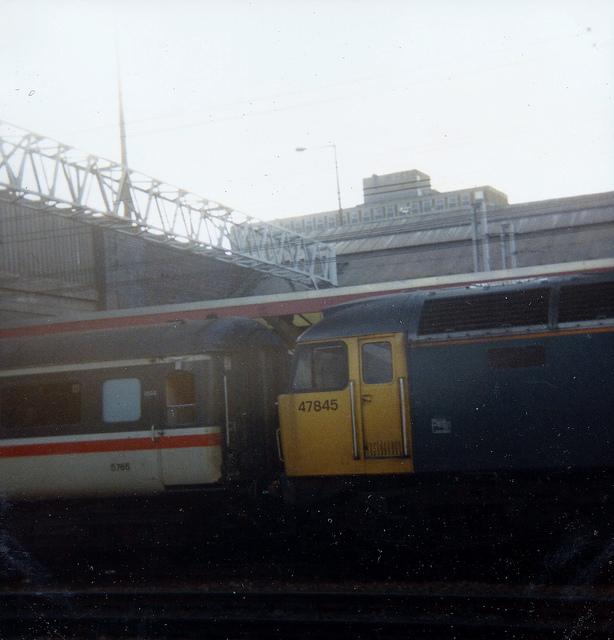How many train cars are there?
Give a very brief answer. 2. What is the train made of?
Answer briefly. Metal. How many trains are crossing the bridge?
Keep it brief. 1. Where is the bridge?
Be succinct. Above train. What is the train number?
Give a very brief answer. 47845. How many trains are blue?
Be succinct. 1. 